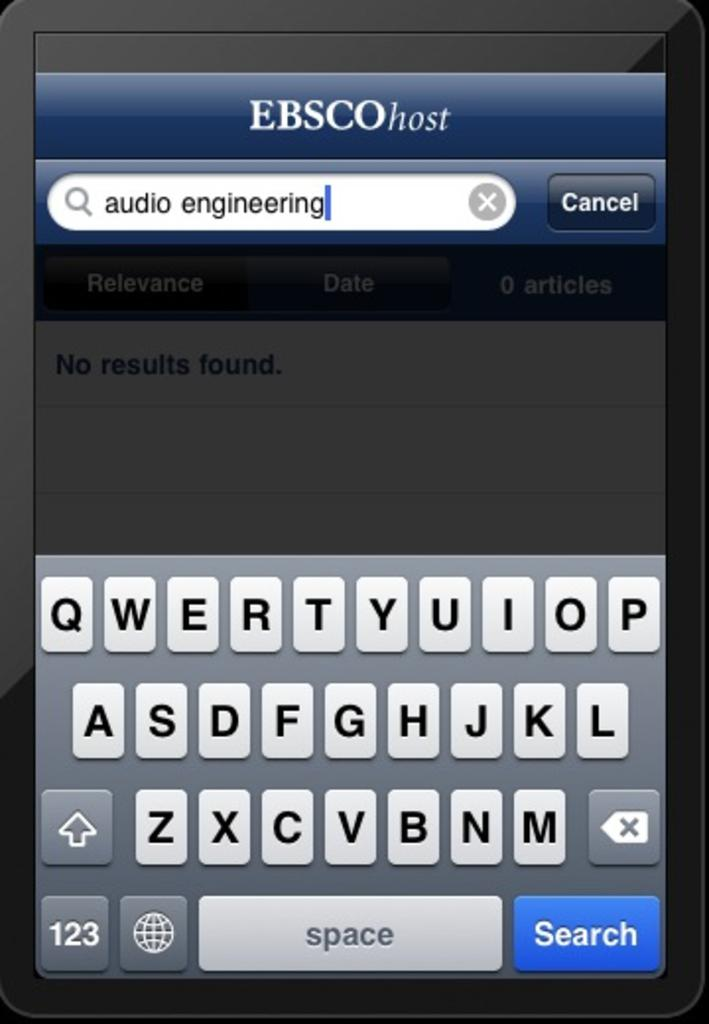What is the main object in the image? There is a mobile screen in the image. What can be seen on the mobile screen? The mobile screen displays alphabets and text. How many pizzas are shown in the image? There are no pizzas present in the image. What type of ant can be seen crawling on the mobile screen? There are no ants present in the image. 